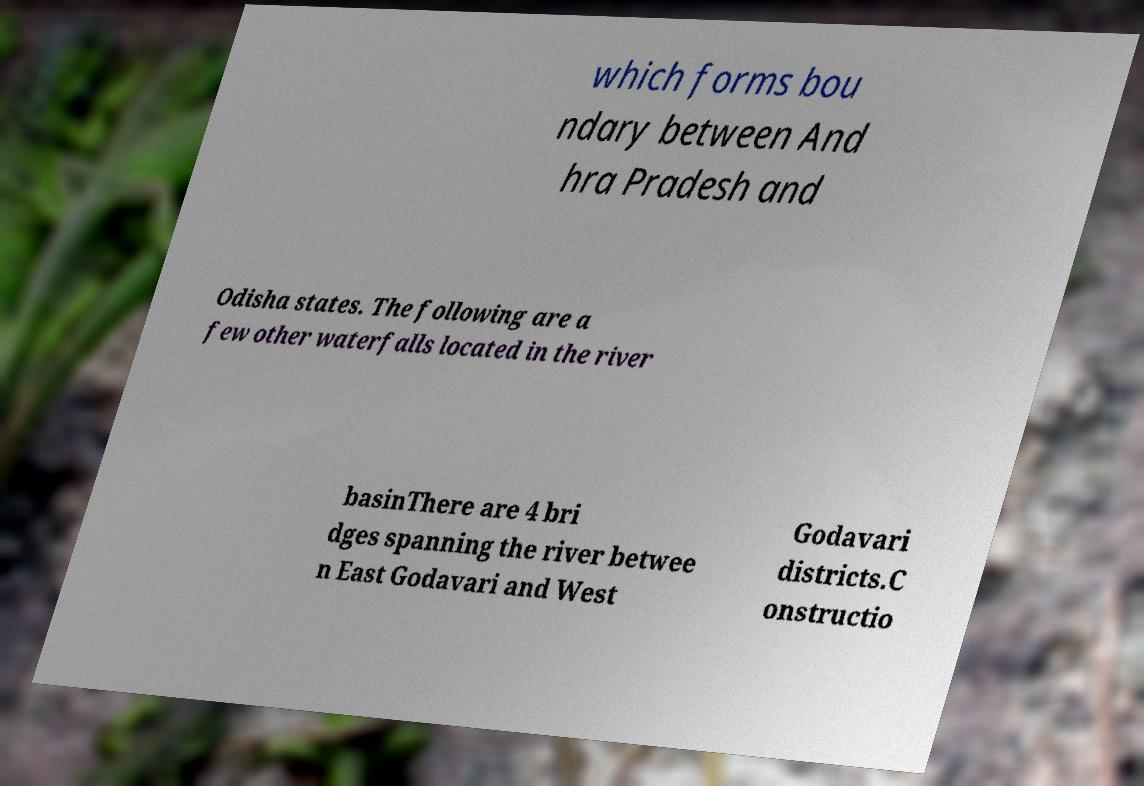Please read and relay the text visible in this image. What does it say? which forms bou ndary between And hra Pradesh and Odisha states. The following are a few other waterfalls located in the river basinThere are 4 bri dges spanning the river betwee n East Godavari and West Godavari districts.C onstructio 